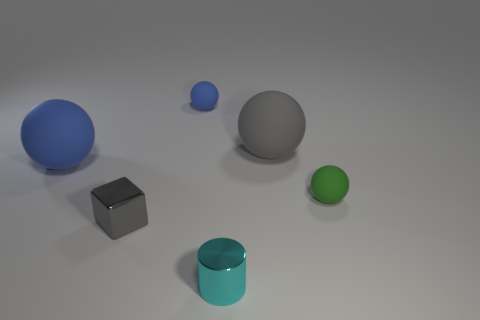Subtract all big blue matte spheres. How many spheres are left? 3 Subtract all brown cylinders. How many blue balls are left? 2 Subtract all gray balls. How many balls are left? 3 Subtract all cyan spheres. Subtract all red cylinders. How many spheres are left? 4 Add 4 yellow metal objects. How many objects exist? 10 Subtract all blocks. How many objects are left? 5 Subtract all purple matte things. Subtract all tiny blue matte balls. How many objects are left? 5 Add 4 big gray objects. How many big gray objects are left? 5 Add 2 tiny gray cylinders. How many tiny gray cylinders exist? 2 Subtract 0 gray cylinders. How many objects are left? 6 